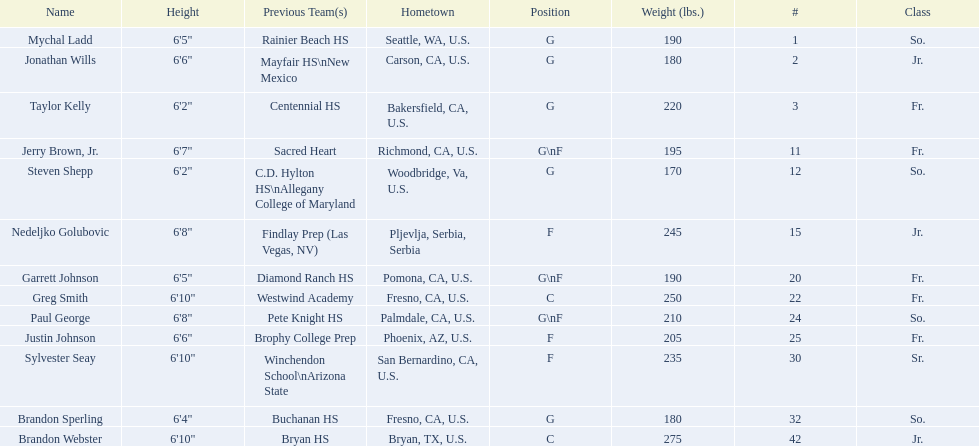Which players are forwards? Nedeljko Golubovic, Paul George, Justin Johnson, Sylvester Seay. What are the heights of these players? Nedeljko Golubovic, 6'8", Paul George, 6'8", Justin Johnson, 6'6", Sylvester Seay, 6'10". Of these players, who is the shortest? Justin Johnson. 